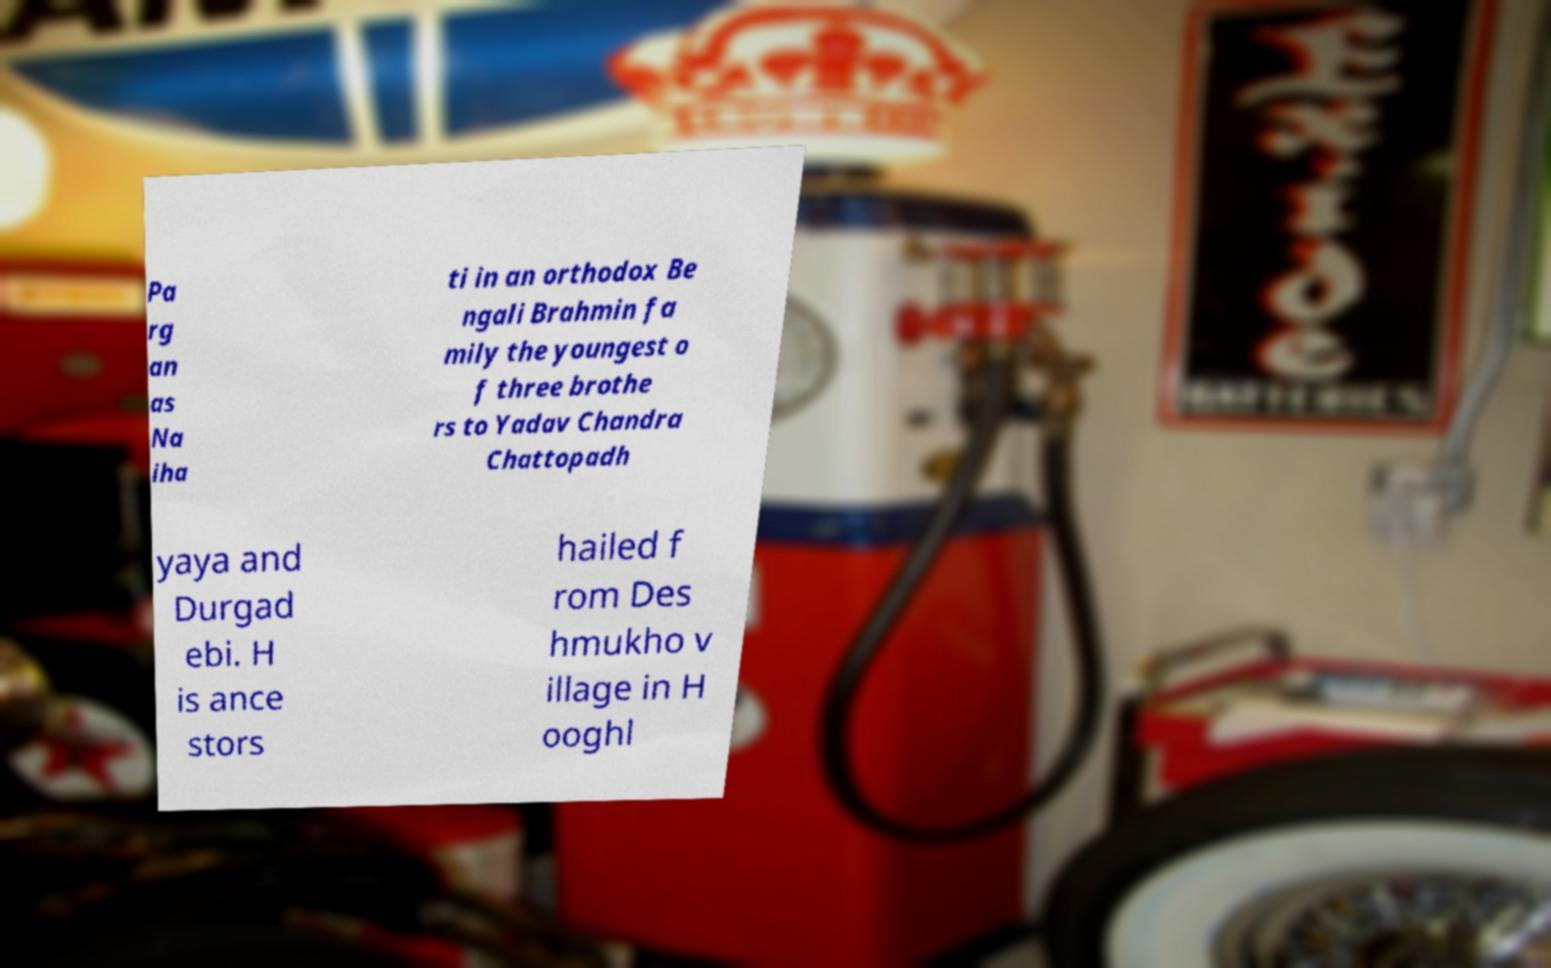Could you assist in decoding the text presented in this image and type it out clearly? Pa rg an as Na iha ti in an orthodox Be ngali Brahmin fa mily the youngest o f three brothe rs to Yadav Chandra Chattopadh yaya and Durgad ebi. H is ance stors hailed f rom Des hmukho v illage in H ooghl 